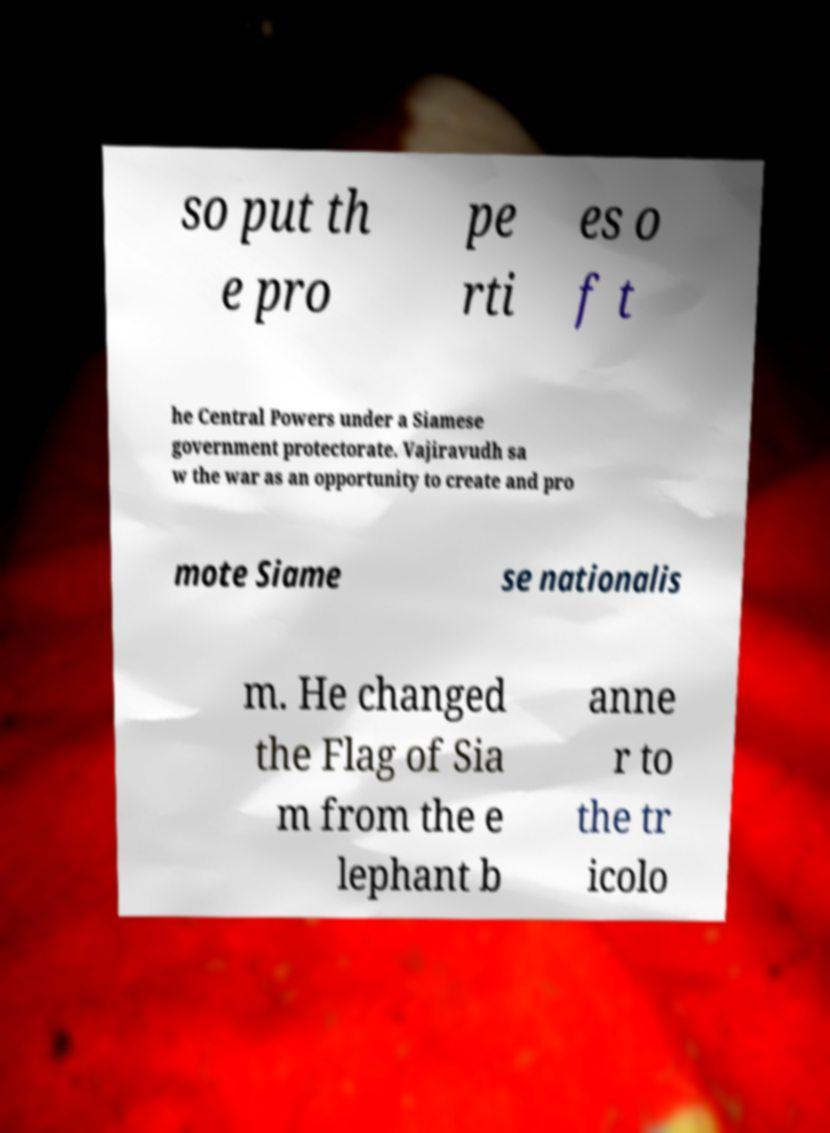For documentation purposes, I need the text within this image transcribed. Could you provide that? so put th e pro pe rti es o f t he Central Powers under a Siamese government protectorate. Vajiravudh sa w the war as an opportunity to create and pro mote Siame se nationalis m. He changed the Flag of Sia m from the e lephant b anne r to the tr icolo 